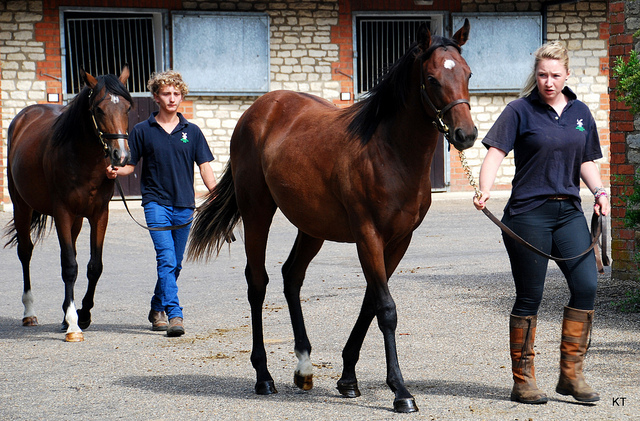Read all the text in this image. KT 